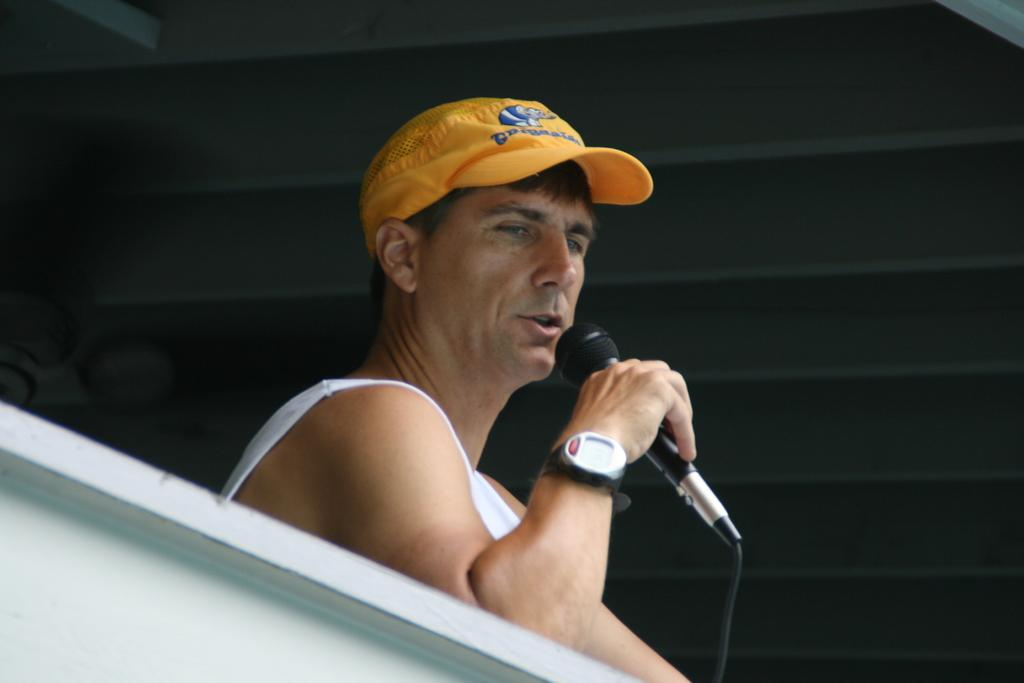What is the person in the image doing? The person is sitting. What object is the person holding in the image? The person is holding a mic. What type of headwear is the person wearing? The person is wearing a cap. What accessory is the person wearing on their wrist? The person is wearing a watch. What color is the wall in the background of the image? The wall in the background of the image is black. Can you see the frame of the ocean in the image? There is no frame of the ocean present in the image; it features a person sitting with a mic and a black wall in the background. 